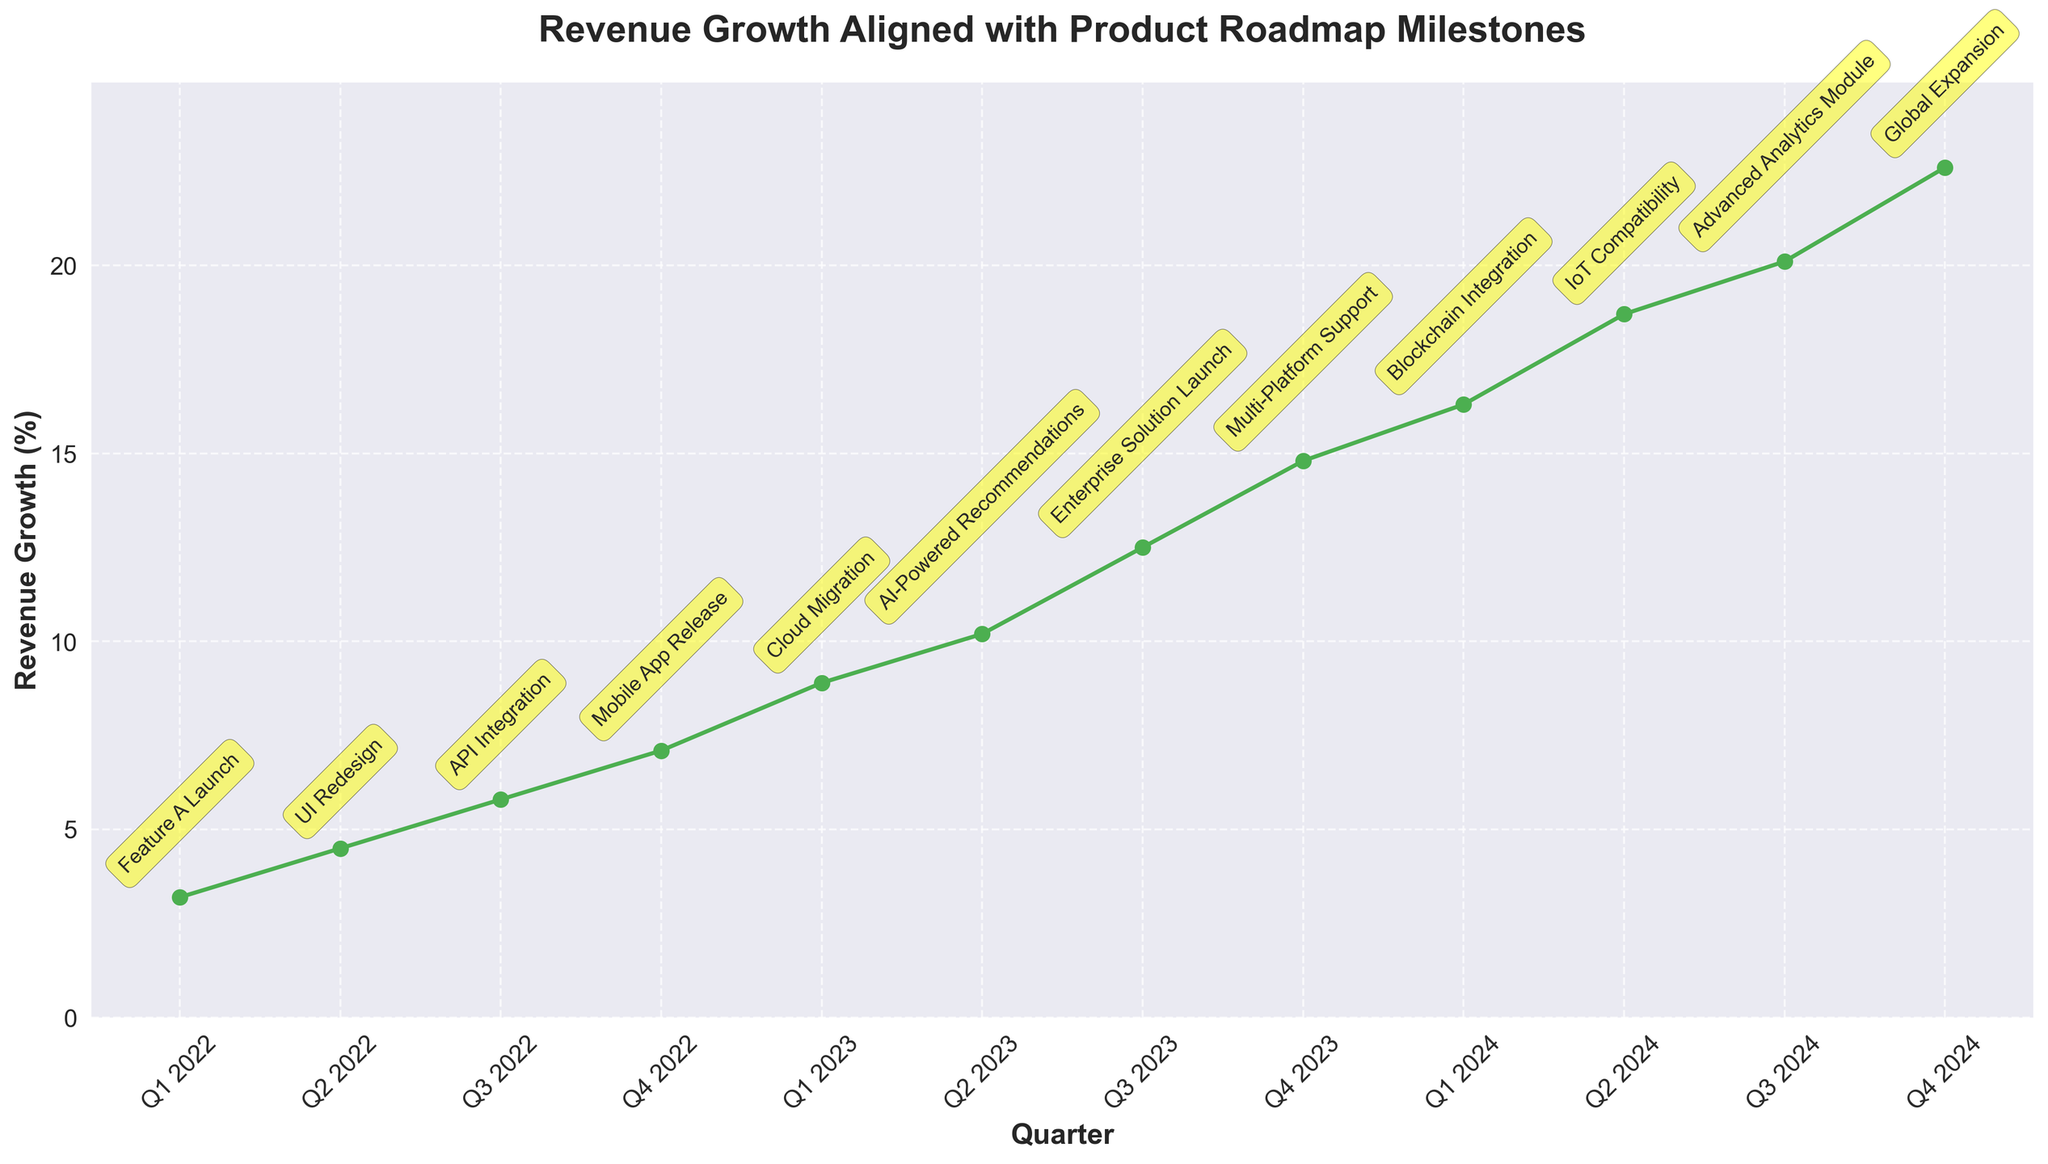What's the quarter with the highest revenue growth? The figure shows a line chart with data points marked, and each point represents a quarter with its corresponding revenue growth. The highest point on the chart is Q4 2024 with the highest revenue growth figure.
Answer: Q4 2024 How did the revenue growth change between the UI Redesign and Mobile App Release milestones? Identify the corresponding quarters for both milestones, which are Q2 2022 and Q4 2022. Compare the revenue growth figures: 4.5% (Q2 2022) to 7.1% (Q4 2022). The change in revenue growth is 7.1% - 4.5% = 2.6%.
Answer: Increased by 2.6% What is the difference in revenue growth between Q3 2023 and Q3 2024? Look at the data points for Q3 2023 and Q3 2024: Q3 2023 shows 12.5% revenue growth, and Q3 2024 shows 20.1%. The difference between these two figures is 20.1% - 12.5% = 7.6%.
Answer: 7.6% What is the average revenue growth in 2023? Identify the quarters for 2023 (Q1 2023, Q2 2023, Q3 2023, Q4 2023) and their corresponding revenue growth percentages: 8.9%, 10.2%, 12.5%, and 14.8%. Calculate the average by summing these values and dividing by the number of quarters: (8.9 + 10.2 + 12.5 + 14.8) / 4 = 46.4 / 4 = 11.6%.
Answer: 11.6% Compare the growth rate between the Feature A Launch and Cloud Migration milestones. The quarters for these milestones are Q1 2022 and Q1 2023. The revenue growth percentages at these points are 3.2% and 8.9%, respectively. Compare these values to find the difference: 8.9% - 3.2% = 5.7%.
Answer: Increased by 5.7% Which milestone resulted in the highest single-quarter revenue growth jump? To determine this, check the difference in revenue growth percentage between consecutive quarters for each milestone. The largest difference can be seen between Q4 2023 and Q1 2024, where growth went from 14.8% to 16.3%, a jump of 1.5%.
Answer: Blockchain Integration How much did revenue growth increase from the start to the end of 2024? Determine the revenue growth at the start (Q1 2024) and end (Q4 2024) of 2024. The values are 16.3% and 22.6% respectively. The increase in revenue growth is 22.6% - 16.3% = 6.3%.
Answer: 6.3% Which product milestone is associated with a revenue growth of around 12.5%? Refer to the chart and find the milestone associated with the data point around 12.5%. This revenue growth is associated with Q3 2023, which corresponds to the Enterprise Solution Launch milestone.
Answer: Enterprise Solution Launch 